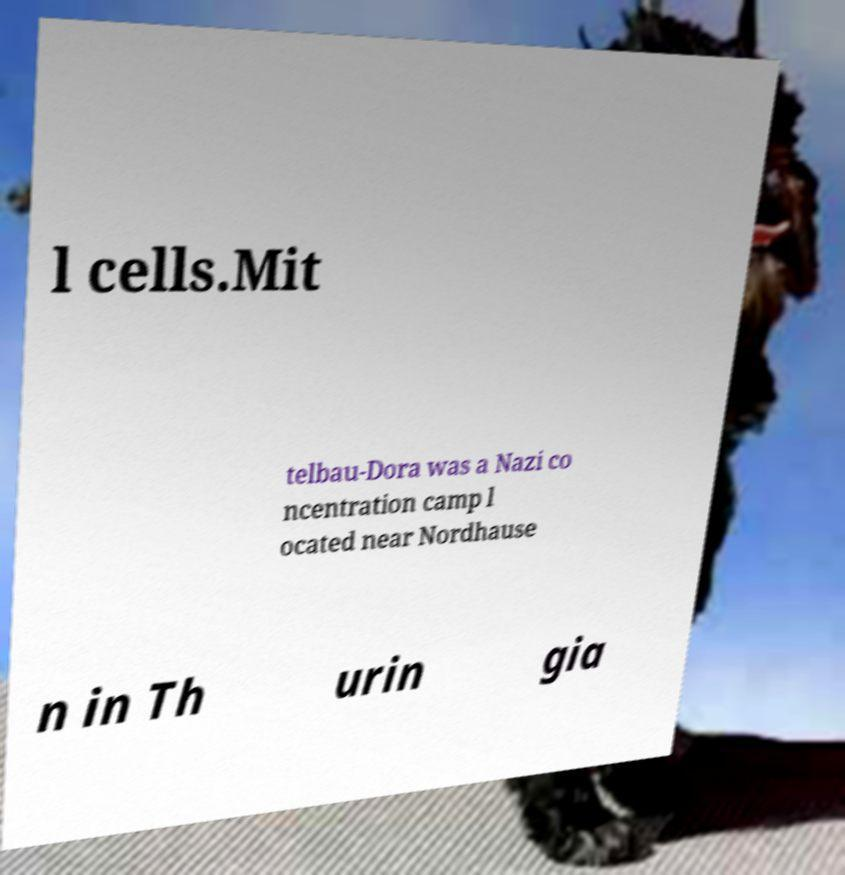Can you read and provide the text displayed in the image?This photo seems to have some interesting text. Can you extract and type it out for me? l cells.Mit telbau-Dora was a Nazi co ncentration camp l ocated near Nordhause n in Th urin gia 